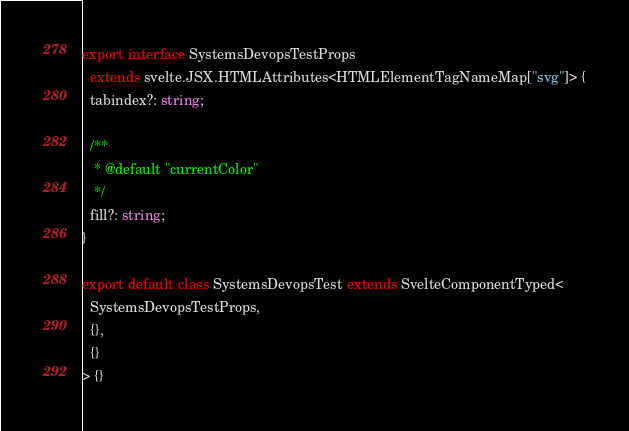Convert code to text. <code><loc_0><loc_0><loc_500><loc_500><_TypeScript_>export interface SystemsDevopsTestProps
  extends svelte.JSX.HTMLAttributes<HTMLElementTagNameMap["svg"]> {
  tabindex?: string;

  /**
   * @default "currentColor"
   */
  fill?: string;
}

export default class SystemsDevopsTest extends SvelteComponentTyped<
  SystemsDevopsTestProps,
  {},
  {}
> {}
</code> 